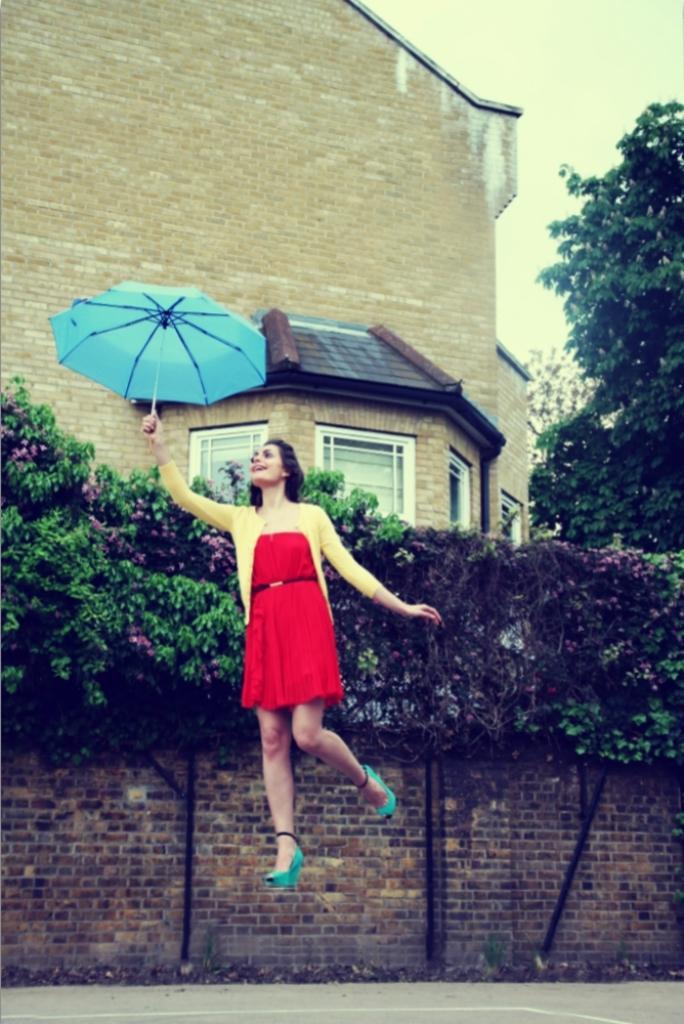Could you give a brief overview of what you see in this image? In this picture there is a girl in the center of the image, by holding an umbrella in her hand and there are trees and a house in the background area of the image. 